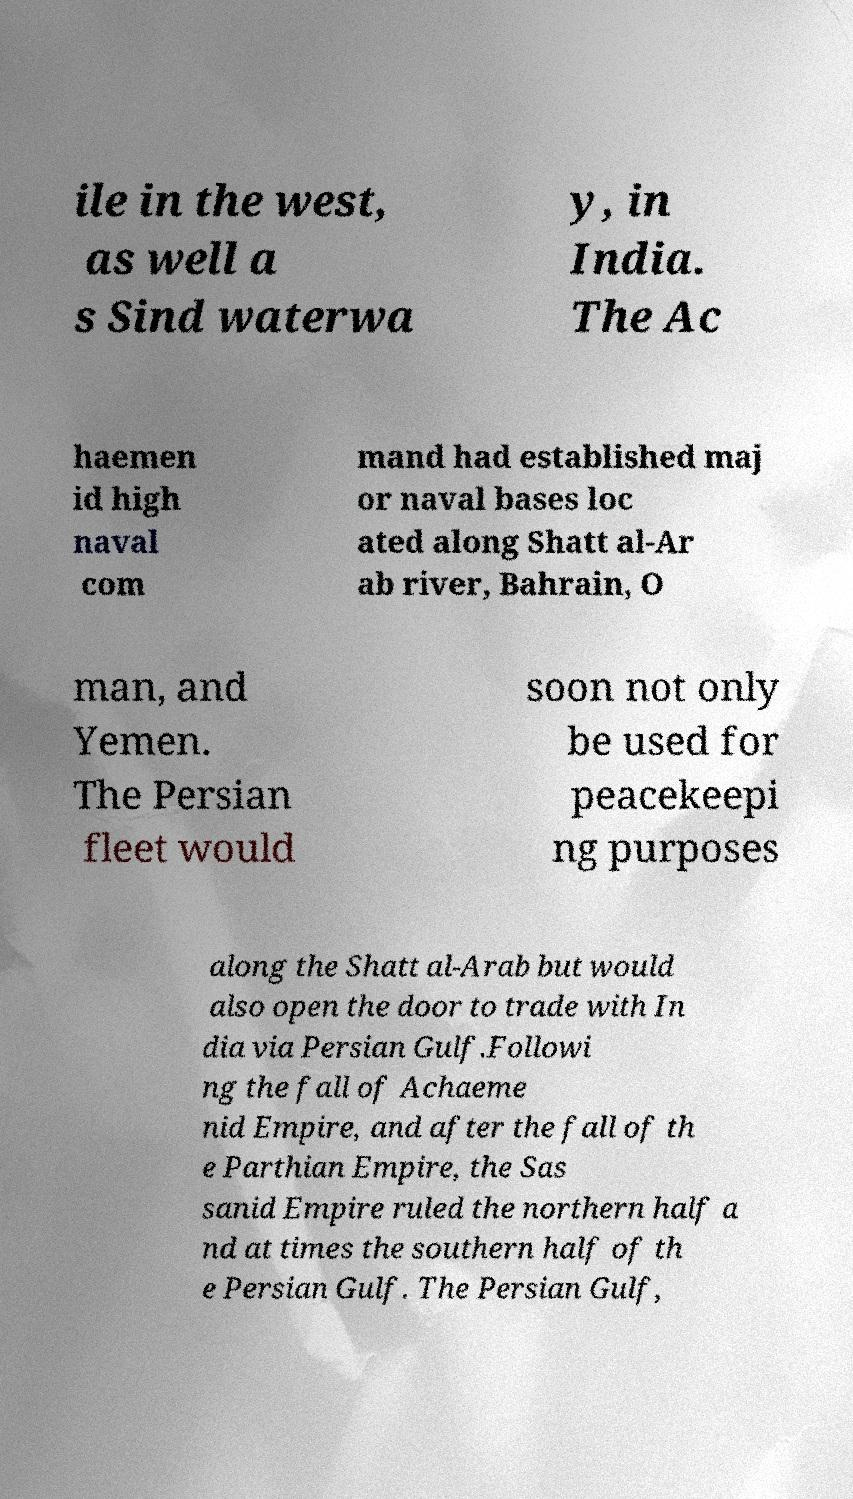Could you extract and type out the text from this image? ile in the west, as well a s Sind waterwa y, in India. The Ac haemen id high naval com mand had established maj or naval bases loc ated along Shatt al-Ar ab river, Bahrain, O man, and Yemen. The Persian fleet would soon not only be used for peacekeepi ng purposes along the Shatt al-Arab but would also open the door to trade with In dia via Persian Gulf.Followi ng the fall of Achaeme nid Empire, and after the fall of th e Parthian Empire, the Sas sanid Empire ruled the northern half a nd at times the southern half of th e Persian Gulf. The Persian Gulf, 